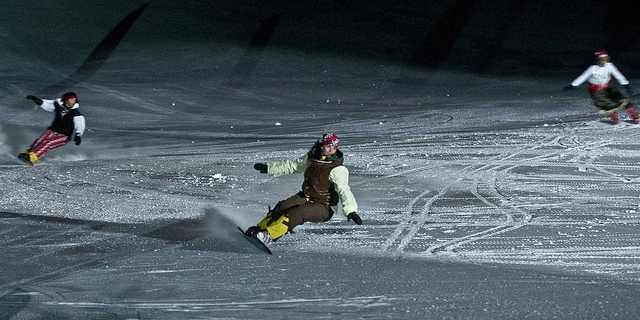Describe the objects in this image and their specific colors. I can see people in black, gray, beige, and darkgray tones, people in black, gray, maroon, and lightgray tones, people in black, lavender, gray, and darkgray tones, snowboard in black, purple, and darkblue tones, and snowboard in black, olive, purple, and maroon tones in this image. 